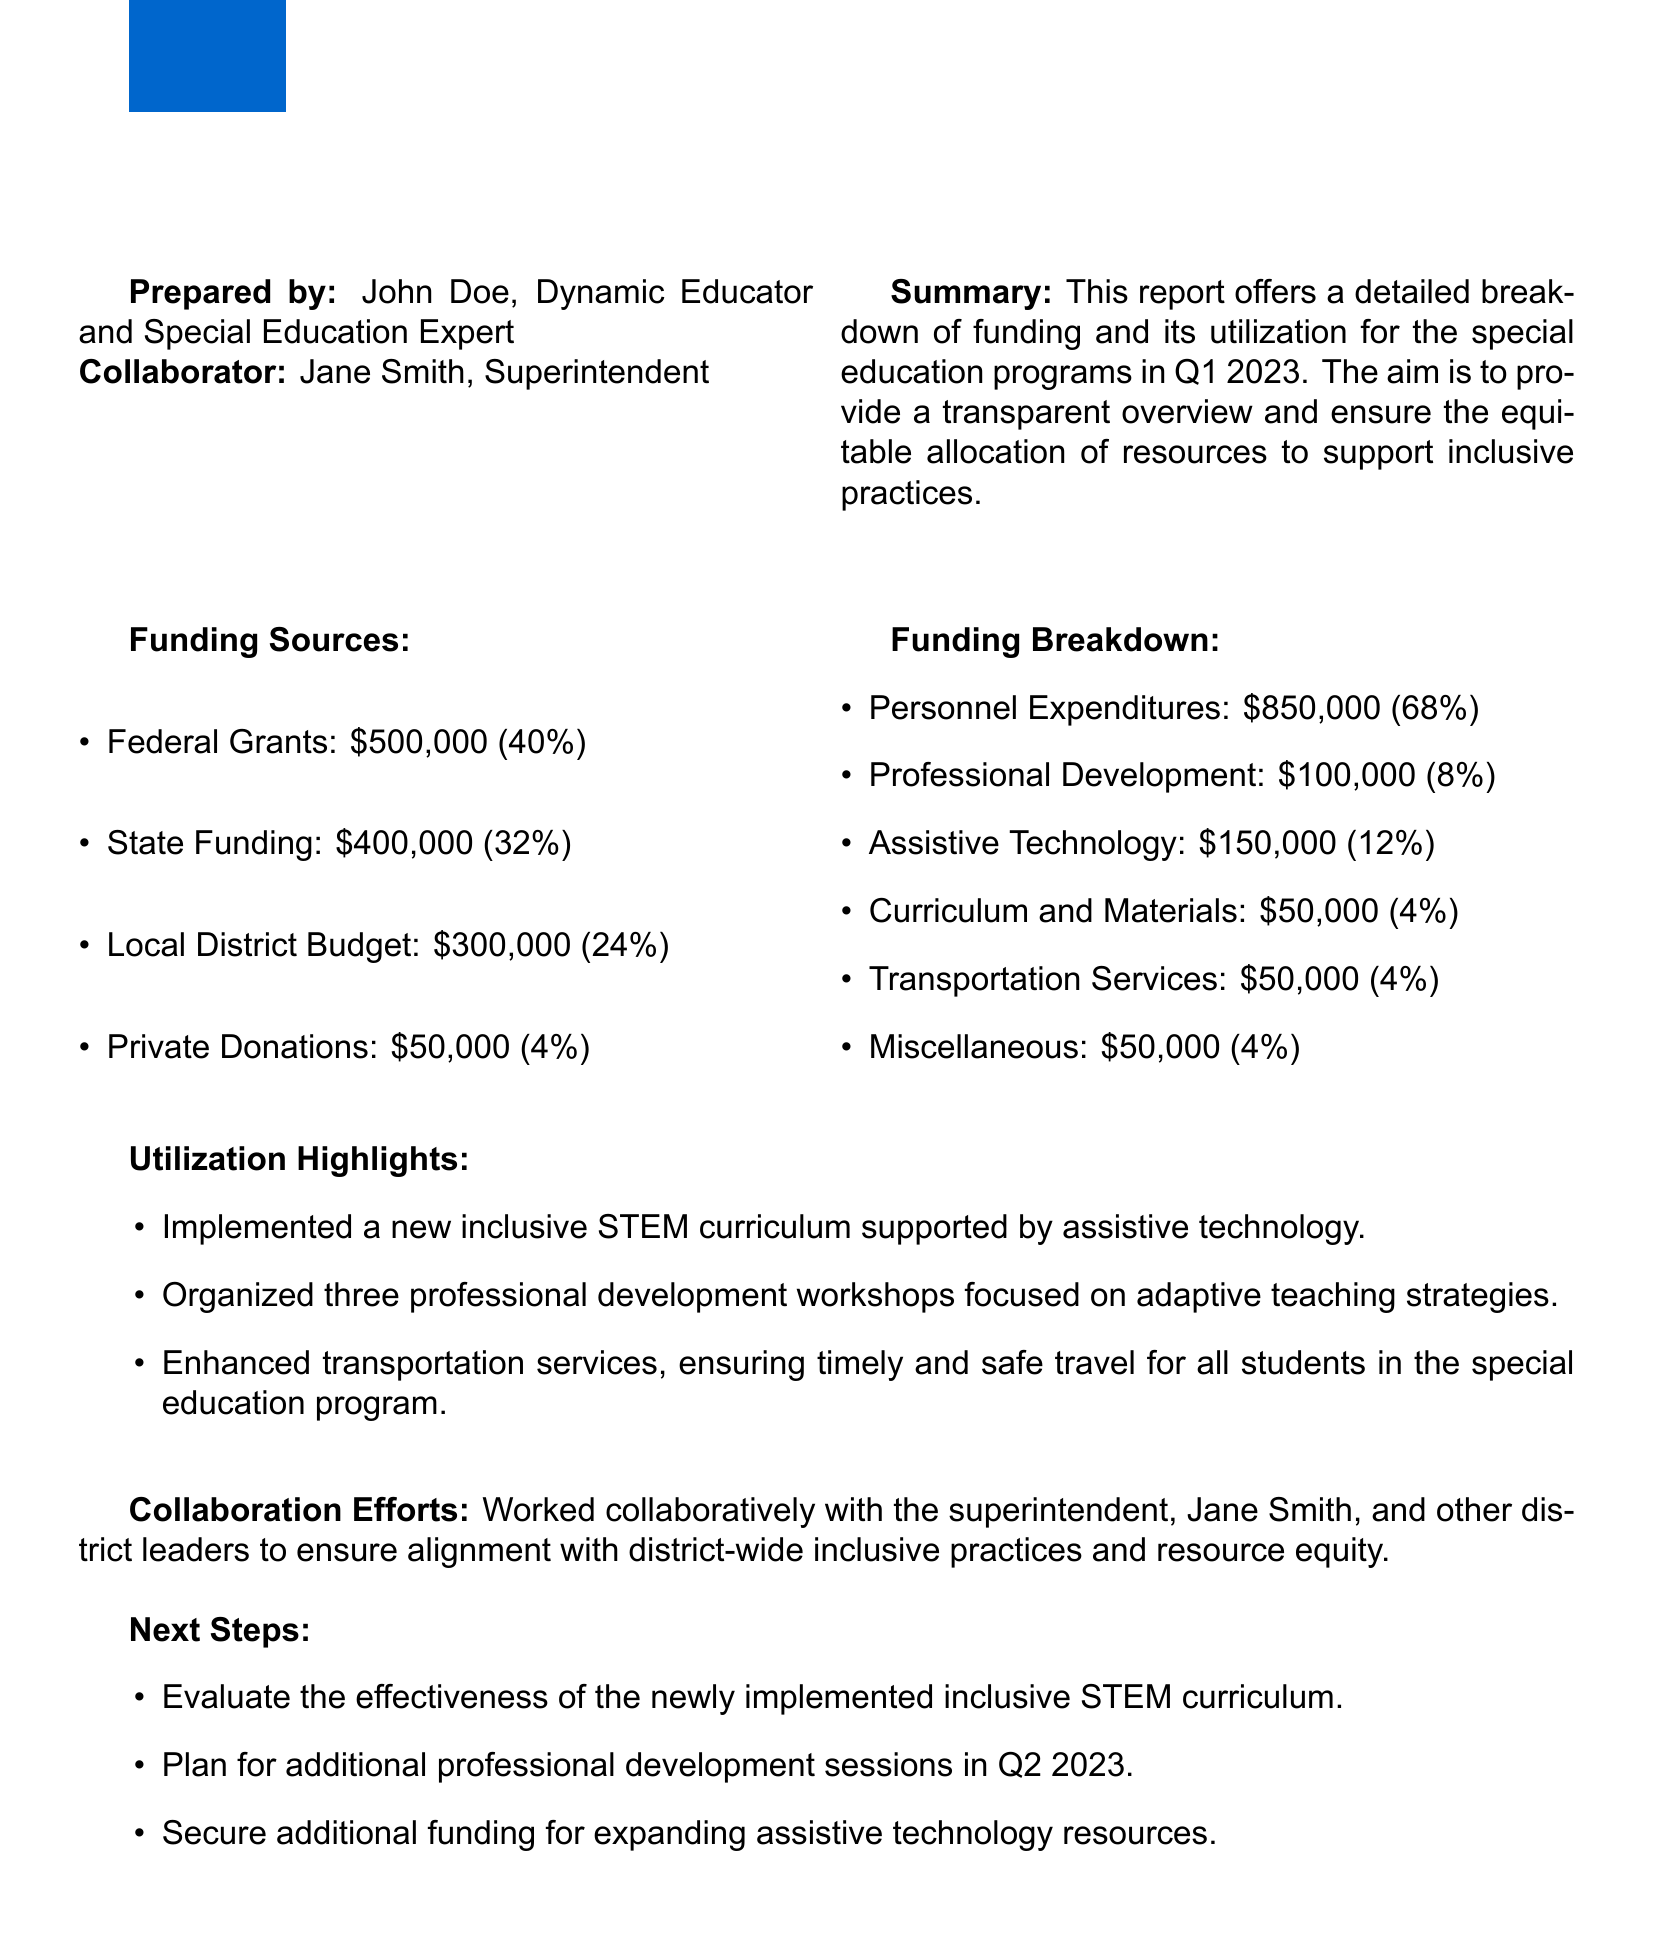what is the total federal funding for Q1 2023? The total federal funding is \$500,000, as stated in the Funding Sources section of the document.
Answer: \$500,000 who prepared the report? The report is prepared by John Doe, as indicated in the document.
Answer: John Doe what percentage of funding is allocated to Personnel Expenditures? The percentage allocated to Personnel Expenditures is 68%, as per the Funding Breakdown section.
Answer: 68% how many professional development workshops were organized? The document mentions that three professional development workshops were organized.
Answer: three what is the total amount of local district budget funding? The total amount of local district budget funding is \$300,000, as shown in the Funding Sources section.
Answer: \$300,000 what is one next step mentioned in the report? One next step mentioned is to evaluate the effectiveness of the newly implemented inclusive STEM curriculum.
Answer: evaluate the effectiveness of the newly implemented inclusive STEM curriculum how is transportation funding utilized in the programs? The document states that \$50,000 is allocated for transportation services, illustrating its significance in student travel.
Answer: \$50,000 who collaborated with John Doe on this report? The report mentions collaboration with Jane Smith, the Superintendent.
Answer: Jane Smith what is the total funding from Private Donations? The document states that the total funding from Private Donations is \$50,000.
Answer: \$50,000 